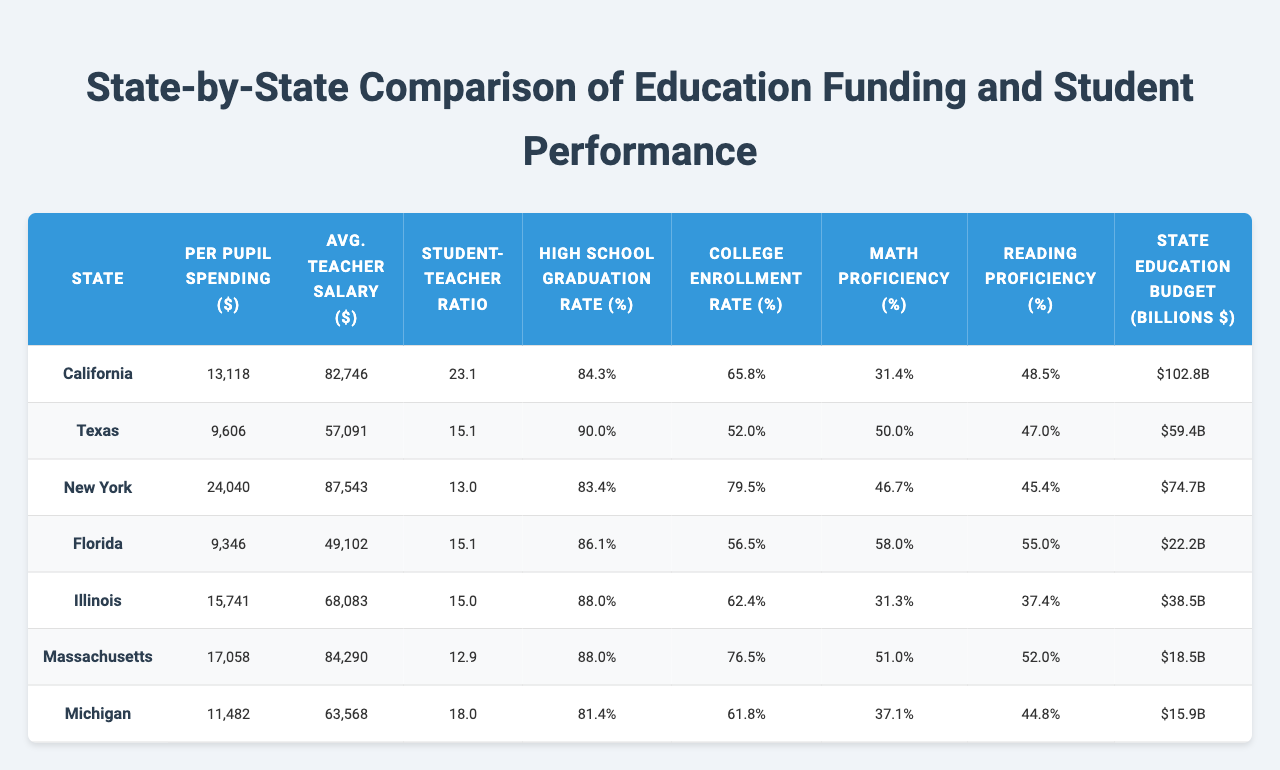What is the per pupil spending in Massachusetts? The table shows that Massachusetts has a per pupil spending of $17,058.
Answer: $17,058 Which state has the highest teacher salary average? Comparing the averages from the table, New York has the highest teacher salary average at $87,543.
Answer: $87,543 What is the student-teacher ratio in Texas? The table lists Texas with a student-teacher ratio of 15.1.
Answer: 15.1 Which state has the lowest math proficiency? By examining the math proficiency column, California has the lowest math proficiency at 31.4%.
Answer: 31.4% What is the college enrollment rate for Illinois? The college enrollment rate for Illinois is given as 62.4% in the table.
Answer: 62.4% Which state has both a high school graduation rate above 90% and a college enrollment rate below 60%? Texas has a high school graduation rate of 90.0% and a college enrollment rate of 52.0%, fulfilling both conditions.
Answer: Texas If we compare the high school graduation rates, how much higher is Texas's rate than California’s? Texas has a rate of 90.0% and California has a rate of 84.3%. The difference is 90.0% - 84.3% = 5.7%.
Answer: 5.7% Is the average teacher salary in Florida greater than the average teacher salary in Michigan? Florida's average teacher salary is $49,102 while Michigan's is $63,568. Since $49,102 is less than $63,568, the statement is false.
Answer: No What is the average per pupil spending of the states provided? To find the average, sum the per pupil spending of all states (California, Texas, New York, Florida, Illinois, Massachusetts, Michigan) = (13118 + 9606 + 24040 + 9346 + 15741 + 17058 + 11482) = 107,391. There are 7 states, so the average is 107,391 / 7 = 15,341.57.
Answer: $15,341.57 Which state spends more on education: California or New York? California spends $13,118 per pupil, while New York spends $24,040 per pupil. Since $24,040 is greater than $13,118, New York spends more.
Answer: New York How does the math proficiency in Florida compare to that in Texas? Florida's math proficiency is 58.0% while Texas's is 50.0%. Florida is higher by 58.0% - 50.0% = 8.0%.
Answer: 8.0% Higher in Florida 